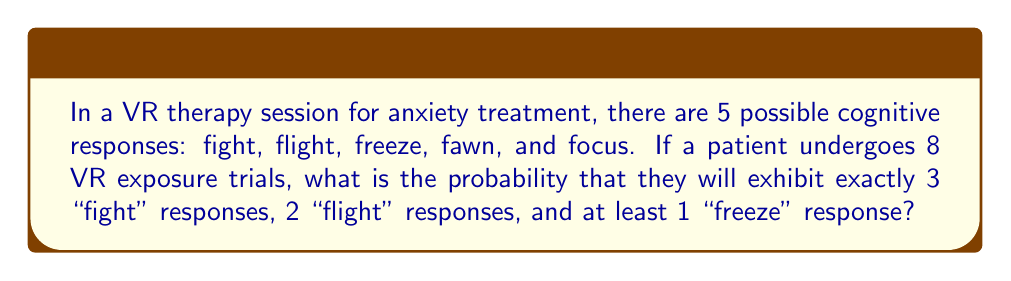Help me with this question. Let's approach this step-by-step:

1) First, we need to use the multinomial distribution to calculate the probability of exactly 3 "fight" responses and 2 "flight" responses in 8 trials.

2) The remaining 3 trials need to be distributed among "freeze", "fawn", and "focus", with the condition that there is at least 1 "freeze" response.

3) The multinomial probability for 3 "fight" and 2 "flight" out of 8 trials is:

   $$P(3\text{ fight}, 2\text{ flight}) = \frac{8!}{3!2!3!} \cdot (\frac{1}{5})^3 \cdot (\frac{1}{5})^2 \cdot (\frac{3}{5})^3$$

4) For the remaining 3 trials, we need to calculate the probability of having at least 1 "freeze". This is equivalent to 1 minus the probability of having no "freeze":

   $$P(\text{at least 1 freeze in 3 trials}) = 1 - (\frac{2}{3})^3$$

5) Combining these probabilities:

   $$P(\text{total}) = \frac{8!}{3!2!3!} \cdot (\frac{1}{5})^3 \cdot (\frac{1}{5})^2 \cdot (\frac{3}{5})^3 \cdot [1 - (\frac{2}{3})^3]$$

6) Calculating:
   $$P(\text{total}) = 56 \cdot (\frac{1}{125}) \cdot (\frac{1}{25}) \cdot (\frac{27}{125}) \cdot (1 - \frac{8}{27})$$
   $$= 56 \cdot \frac{27}{390625} \cdot \frac{19}{27} = \frac{28728}{390625} \approx 0.0735$$
Answer: $\frac{28728}{390625}$ 